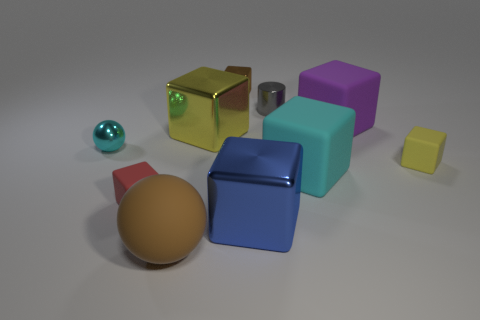Subtract all brown cubes. How many cubes are left? 6 Subtract all blue cylinders. How many yellow cubes are left? 2 Subtract all purple cubes. How many cubes are left? 6 Subtract 3 cubes. How many cubes are left? 4 Subtract all blocks. How many objects are left? 3 Add 1 big cyan things. How many big cyan things are left? 2 Add 8 yellow matte things. How many yellow matte things exist? 9 Subtract 1 blue blocks. How many objects are left? 9 Subtract all blue spheres. Subtract all brown blocks. How many spheres are left? 2 Subtract all cyan matte things. Subtract all tiny blocks. How many objects are left? 6 